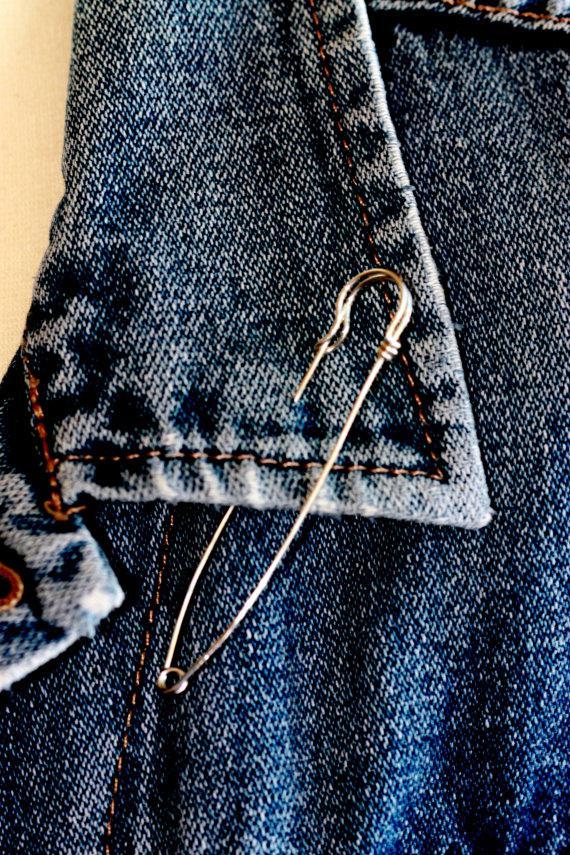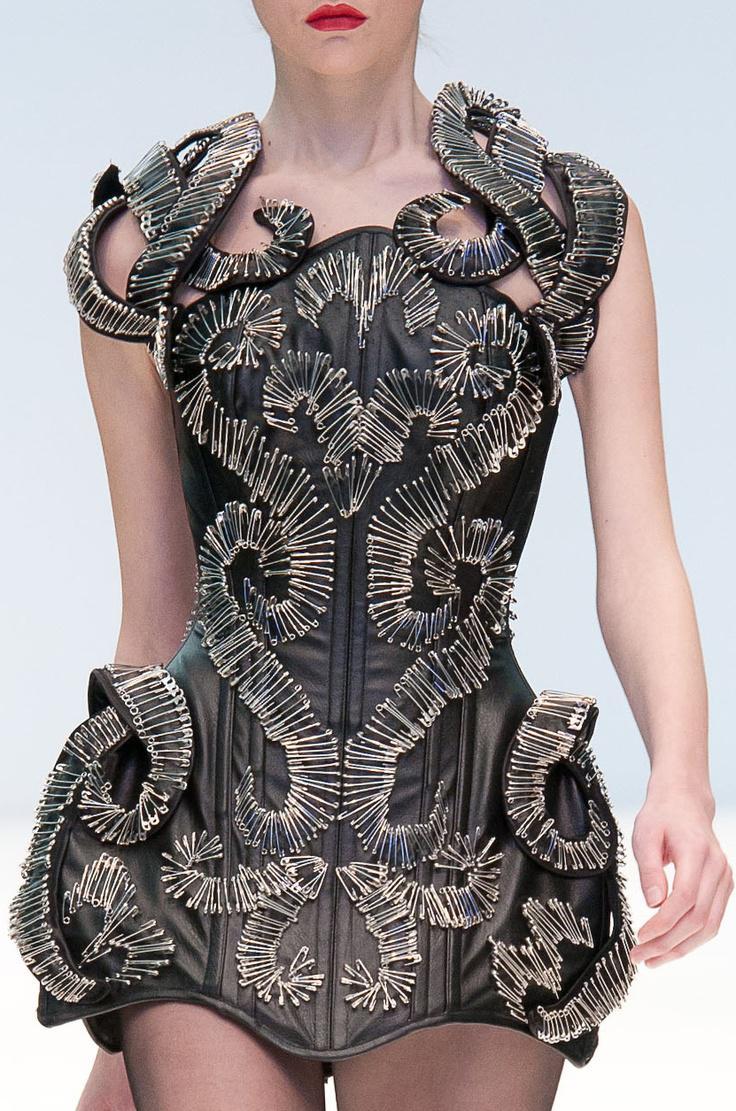The first image is the image on the left, the second image is the image on the right. Considering the images on both sides, is "One of the images shows both the legs and arms of a model." valid? Answer yes or no. Yes. The first image is the image on the left, the second image is the image on the right. Examine the images to the left and right. Is the description "bobby pins are worn as a bracelet on a himan wrist" accurate? Answer yes or no. No. 